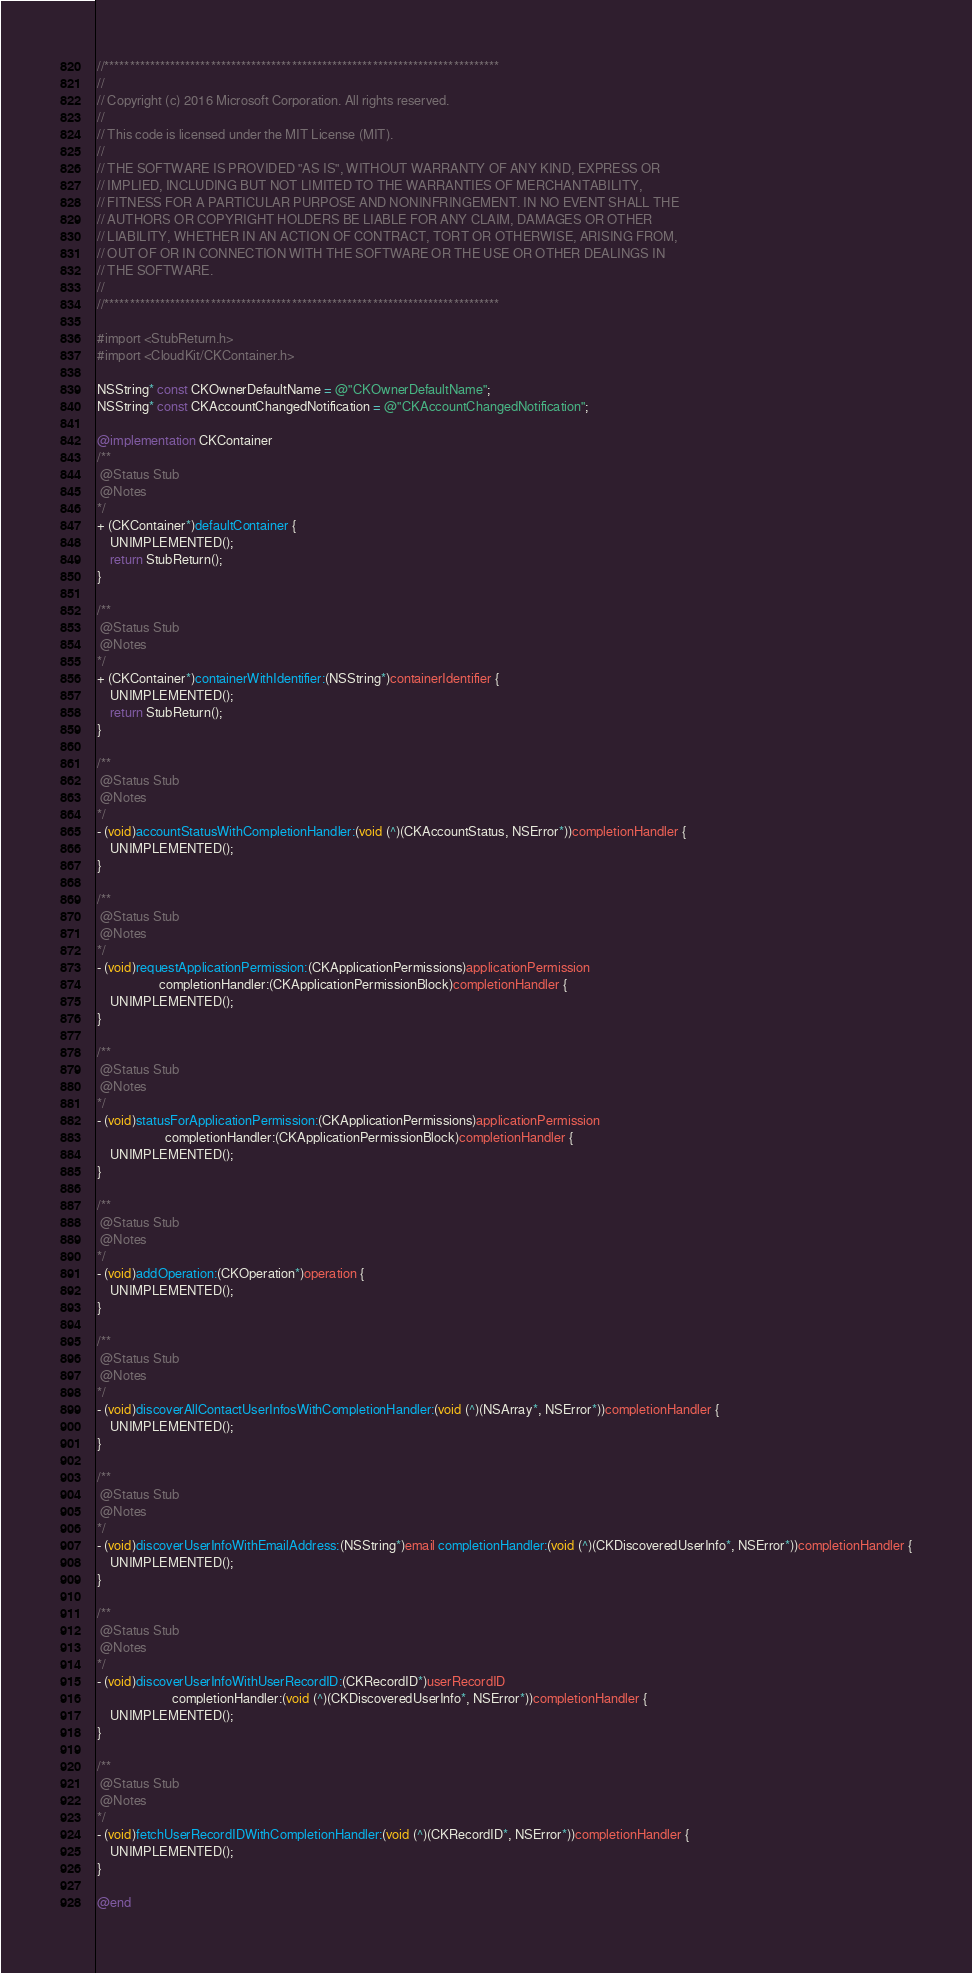Convert code to text. <code><loc_0><loc_0><loc_500><loc_500><_ObjectiveC_>//******************************************************************************
//
// Copyright (c) 2016 Microsoft Corporation. All rights reserved.
//
// This code is licensed under the MIT License (MIT).
//
// THE SOFTWARE IS PROVIDED "AS IS", WITHOUT WARRANTY OF ANY KIND, EXPRESS OR
// IMPLIED, INCLUDING BUT NOT LIMITED TO THE WARRANTIES OF MERCHANTABILITY,
// FITNESS FOR A PARTICULAR PURPOSE AND NONINFRINGEMENT. IN NO EVENT SHALL THE
// AUTHORS OR COPYRIGHT HOLDERS BE LIABLE FOR ANY CLAIM, DAMAGES OR OTHER
// LIABILITY, WHETHER IN AN ACTION OF CONTRACT, TORT OR OTHERWISE, ARISING FROM,
// OUT OF OR IN CONNECTION WITH THE SOFTWARE OR THE USE OR OTHER DEALINGS IN
// THE SOFTWARE.
//
//******************************************************************************

#import <StubReturn.h>
#import <CloudKit/CKContainer.h>

NSString* const CKOwnerDefaultName = @"CKOwnerDefaultName";
NSString* const CKAccountChangedNotification = @"CKAccountChangedNotification";

@implementation CKContainer
/**
 @Status Stub
 @Notes
*/
+ (CKContainer*)defaultContainer {
    UNIMPLEMENTED();
    return StubReturn();
}

/**
 @Status Stub
 @Notes
*/
+ (CKContainer*)containerWithIdentifier:(NSString*)containerIdentifier {
    UNIMPLEMENTED();
    return StubReturn();
}

/**
 @Status Stub
 @Notes
*/
- (void)accountStatusWithCompletionHandler:(void (^)(CKAccountStatus, NSError*))completionHandler {
    UNIMPLEMENTED();
}

/**
 @Status Stub
 @Notes
*/
- (void)requestApplicationPermission:(CKApplicationPermissions)applicationPermission
                   completionHandler:(CKApplicationPermissionBlock)completionHandler {
    UNIMPLEMENTED();
}

/**
 @Status Stub
 @Notes
*/
- (void)statusForApplicationPermission:(CKApplicationPermissions)applicationPermission
                     completionHandler:(CKApplicationPermissionBlock)completionHandler {
    UNIMPLEMENTED();
}

/**
 @Status Stub
 @Notes
*/
- (void)addOperation:(CKOperation*)operation {
    UNIMPLEMENTED();
}

/**
 @Status Stub
 @Notes
*/
- (void)discoverAllContactUserInfosWithCompletionHandler:(void (^)(NSArray*, NSError*))completionHandler {
    UNIMPLEMENTED();
}

/**
 @Status Stub
 @Notes
*/
- (void)discoverUserInfoWithEmailAddress:(NSString*)email completionHandler:(void (^)(CKDiscoveredUserInfo*, NSError*))completionHandler {
    UNIMPLEMENTED();
}

/**
 @Status Stub
 @Notes
*/
- (void)discoverUserInfoWithUserRecordID:(CKRecordID*)userRecordID
                       completionHandler:(void (^)(CKDiscoveredUserInfo*, NSError*))completionHandler {
    UNIMPLEMENTED();
}

/**
 @Status Stub
 @Notes
*/
- (void)fetchUserRecordIDWithCompletionHandler:(void (^)(CKRecordID*, NSError*))completionHandler {
    UNIMPLEMENTED();
}

@end
</code> 